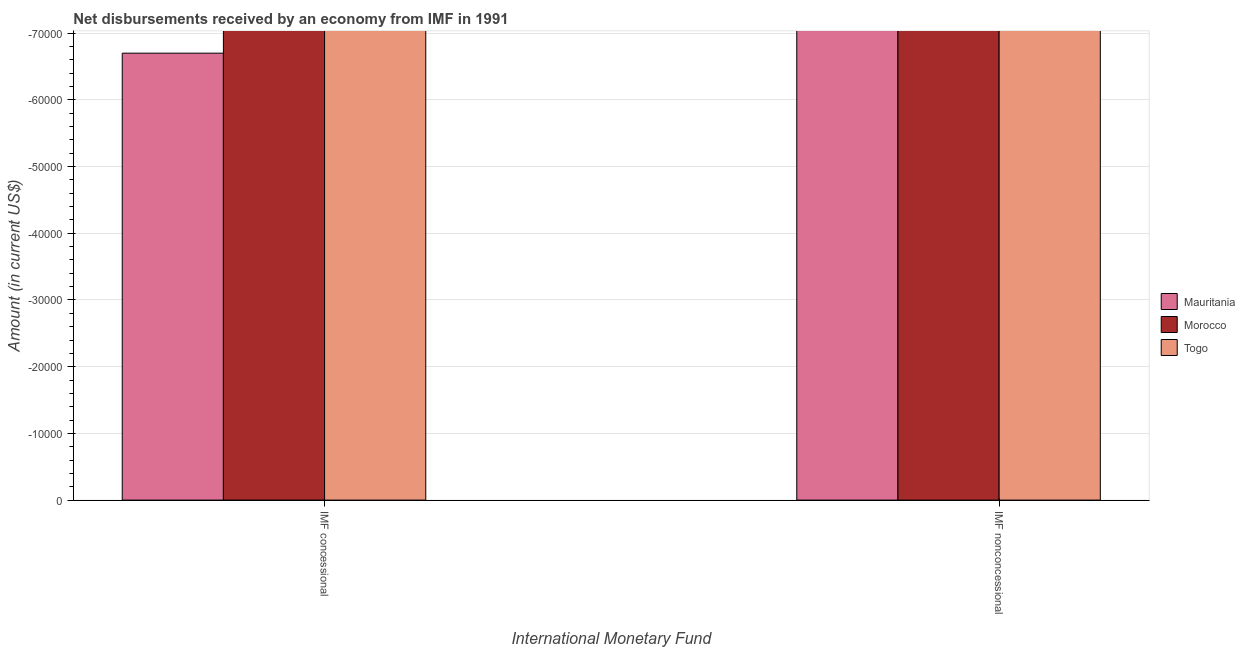How many different coloured bars are there?
Ensure brevity in your answer.  0. How many bars are there on the 1st tick from the left?
Give a very brief answer. 0. What is the label of the 1st group of bars from the left?
Offer a terse response. IMF concessional. What is the net non concessional disbursements from imf in Mauritania?
Your answer should be compact. 0. Across all countries, what is the minimum net concessional disbursements from imf?
Your answer should be compact. 0. What is the total net concessional disbursements from imf in the graph?
Your response must be concise. 0. What is the difference between the net non concessional disbursements from imf in Togo and the net concessional disbursements from imf in Morocco?
Ensure brevity in your answer.  0. What is the average net concessional disbursements from imf per country?
Your answer should be very brief. 0. How many countries are there in the graph?
Keep it short and to the point. 3. What is the difference between two consecutive major ticks on the Y-axis?
Your response must be concise. 10000. Are the values on the major ticks of Y-axis written in scientific E-notation?
Provide a succinct answer. No. Does the graph contain grids?
Provide a short and direct response. Yes. How many legend labels are there?
Your answer should be very brief. 3. How are the legend labels stacked?
Your response must be concise. Vertical. What is the title of the graph?
Make the answer very short. Net disbursements received by an economy from IMF in 1991. What is the label or title of the X-axis?
Ensure brevity in your answer.  International Monetary Fund. What is the label or title of the Y-axis?
Keep it short and to the point. Amount (in current US$). What is the Amount (in current US$) in Morocco in IMF concessional?
Offer a terse response. 0. What is the total Amount (in current US$) of Mauritania in the graph?
Give a very brief answer. 0. What is the total Amount (in current US$) of Morocco in the graph?
Offer a very short reply. 0. What is the total Amount (in current US$) in Togo in the graph?
Ensure brevity in your answer.  0. What is the average Amount (in current US$) in Togo per International Monetary Fund?
Offer a very short reply. 0. 